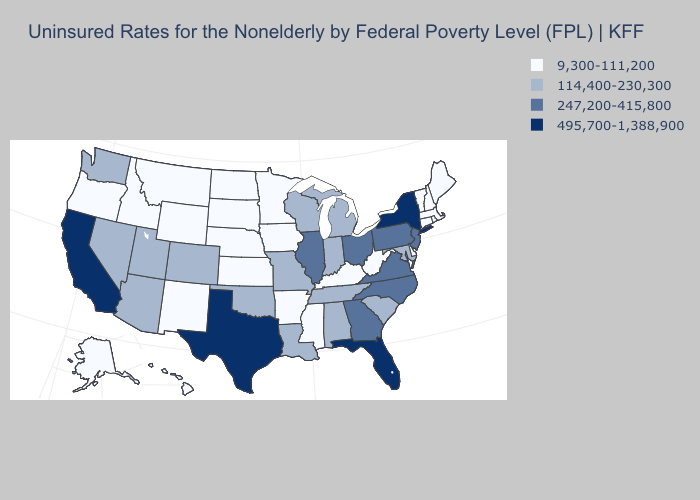What is the value of Massachusetts?
Write a very short answer. 9,300-111,200. Which states have the lowest value in the USA?
Quick response, please. Alaska, Arkansas, Connecticut, Delaware, Hawaii, Idaho, Iowa, Kansas, Kentucky, Maine, Massachusetts, Minnesota, Mississippi, Montana, Nebraska, New Hampshire, New Mexico, North Dakota, Oregon, Rhode Island, South Dakota, Vermont, West Virginia, Wyoming. Which states have the lowest value in the USA?
Quick response, please. Alaska, Arkansas, Connecticut, Delaware, Hawaii, Idaho, Iowa, Kansas, Kentucky, Maine, Massachusetts, Minnesota, Mississippi, Montana, Nebraska, New Hampshire, New Mexico, North Dakota, Oregon, Rhode Island, South Dakota, Vermont, West Virginia, Wyoming. What is the lowest value in the MidWest?
Keep it brief. 9,300-111,200. What is the value of Kansas?
Write a very short answer. 9,300-111,200. What is the highest value in states that border North Dakota?
Quick response, please. 9,300-111,200. How many symbols are there in the legend?
Answer briefly. 4. Among the states that border Oklahoma , does Texas have the highest value?
Keep it brief. Yes. What is the value of Tennessee?
Keep it brief. 114,400-230,300. Which states have the lowest value in the USA?
Keep it brief. Alaska, Arkansas, Connecticut, Delaware, Hawaii, Idaho, Iowa, Kansas, Kentucky, Maine, Massachusetts, Minnesota, Mississippi, Montana, Nebraska, New Hampshire, New Mexico, North Dakota, Oregon, Rhode Island, South Dakota, Vermont, West Virginia, Wyoming. What is the highest value in the Northeast ?
Short answer required. 495,700-1,388,900. What is the lowest value in states that border North Dakota?
Keep it brief. 9,300-111,200. Does Idaho have a higher value than Rhode Island?
Write a very short answer. No. What is the value of Mississippi?
Give a very brief answer. 9,300-111,200. Name the states that have a value in the range 9,300-111,200?
Answer briefly. Alaska, Arkansas, Connecticut, Delaware, Hawaii, Idaho, Iowa, Kansas, Kentucky, Maine, Massachusetts, Minnesota, Mississippi, Montana, Nebraska, New Hampshire, New Mexico, North Dakota, Oregon, Rhode Island, South Dakota, Vermont, West Virginia, Wyoming. 